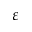<formula> <loc_0><loc_0><loc_500><loc_500>\varepsilon</formula> 